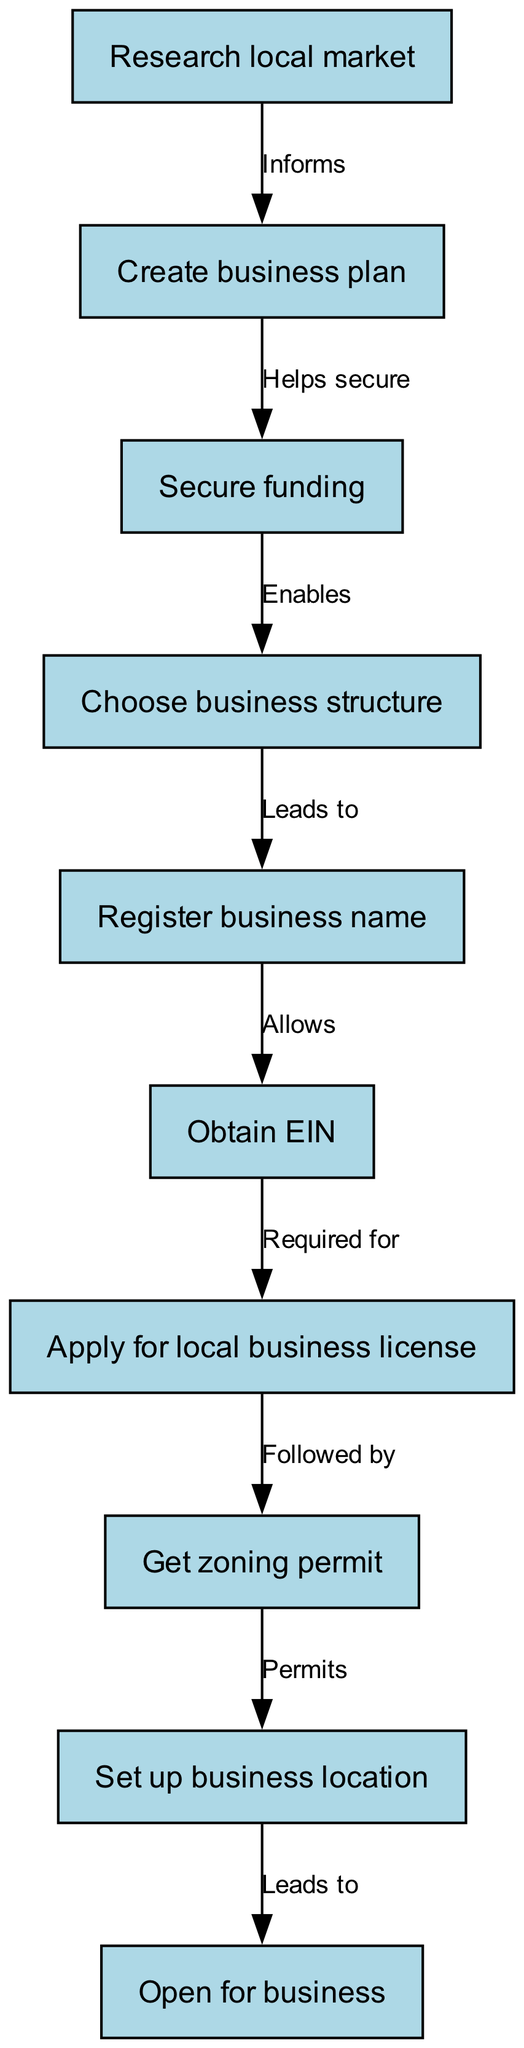What is the first step in starting a small business according to the diagram? The diagram indicates that the first step is to "Research local market," as it is the first node presented.
Answer: Research local market How many nodes are there in the diagram? There are ten nodes in the diagram, as listed from node 1 to node 10.
Answer: 10 What does the "Create business plan" node inform? The diagram shows that "Research local market" informs "Create business plan," indicating the relationship between these two steps.
Answer: Research local market Which step follows after obtaining the EIN? The diagram specifies that after obtaining the EIN, the next step is to "Apply for local business license," indicating the sequence of steps.
Answer: Apply for local business license What is the last step in the business start-up process? According to the diagram, the last step is to "Open for business," which is the final node.
Answer: Open for business What is required for obtaining a local business license? The diagram illustrates that obtaining an EIN is required for applying for a local business license, linking the necessary steps in the process.
Answer: EIN What leads to registering the business name? The diagram indicates that choosing a business structure leads to registering the business name, showing the flow of the process.
Answer: Choosing business structure What permits are required after obtaining a local business license? The diagram states that after applying for a local business license, obtaining a zoning permit is required, showing the sequence of necessary permits.
Answer: Zoning permit 